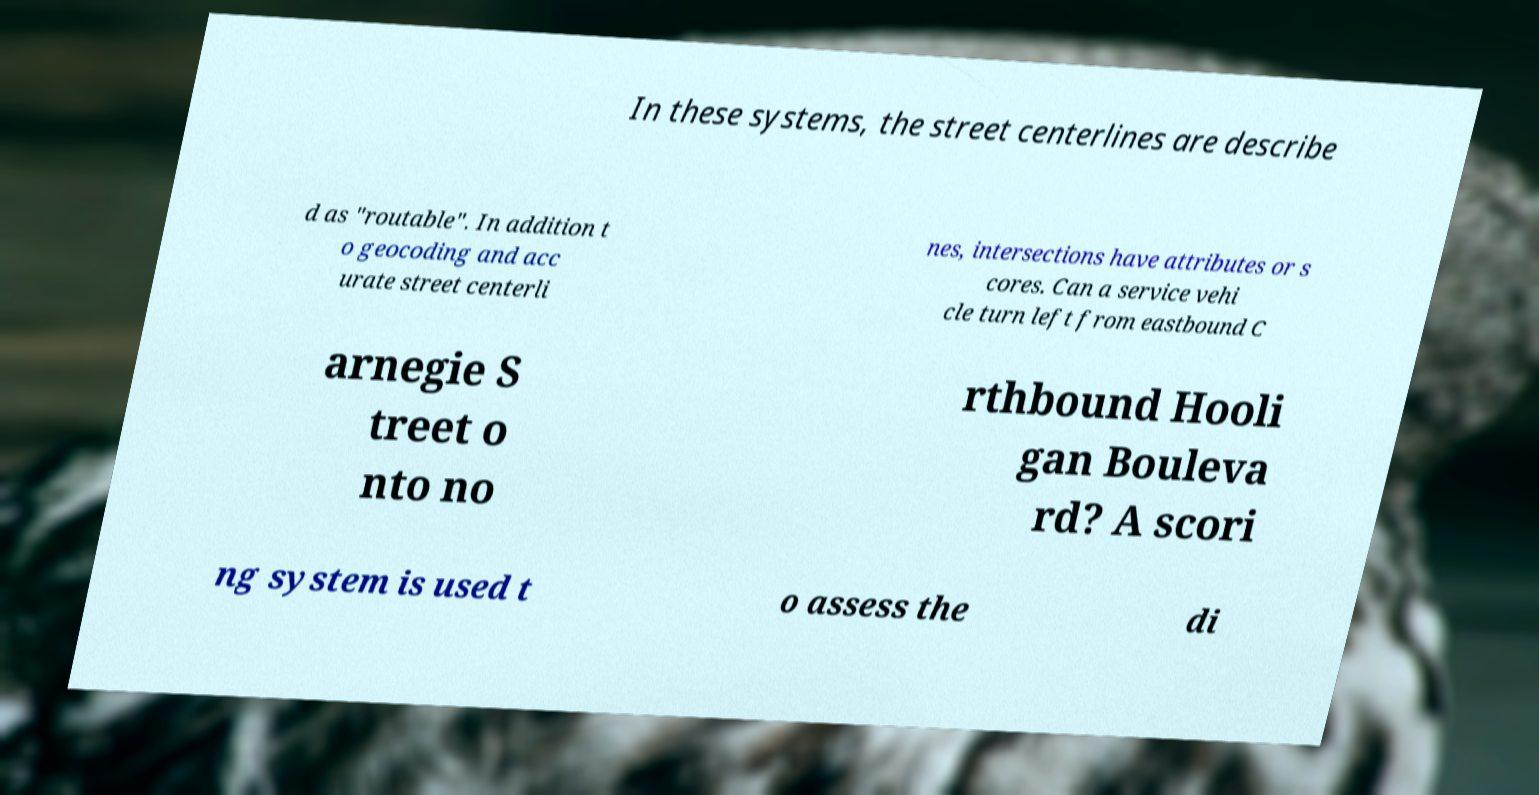There's text embedded in this image that I need extracted. Can you transcribe it verbatim? In these systems, the street centerlines are describe d as "routable". In addition t o geocoding and acc urate street centerli nes, intersections have attributes or s cores. Can a service vehi cle turn left from eastbound C arnegie S treet o nto no rthbound Hooli gan Bouleva rd? A scori ng system is used t o assess the di 